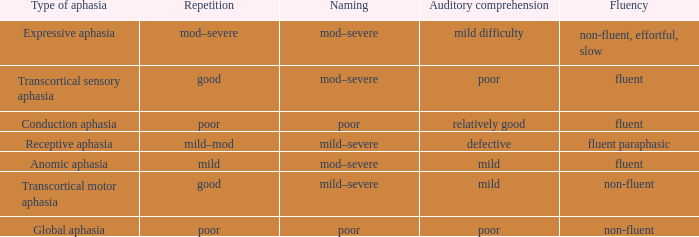Name the fluency for transcortical sensory aphasia Fluent. 